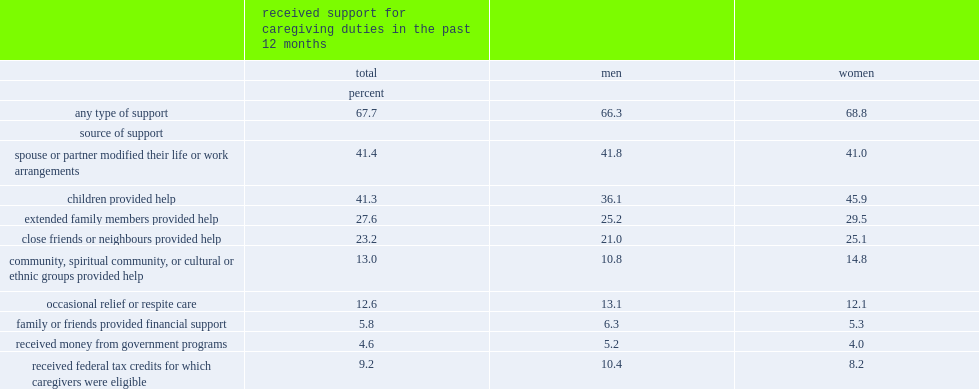What the percent of senior caregivers reported that they had received support for their caregiving duties from at least one of the nine sources? 67.7. What the percent of the most common sources of support for senior caregivers were help from their children? 41.3. What the percent of the most common sources of support for senior caregivers were help in the form of a spouse or partner modifying their life or work arrangements? 41.4. What the percent of senior caregivers received support from extended family? 27.6. What the percent of senior caregivers received support from close friends and neighbours. 23.2. 